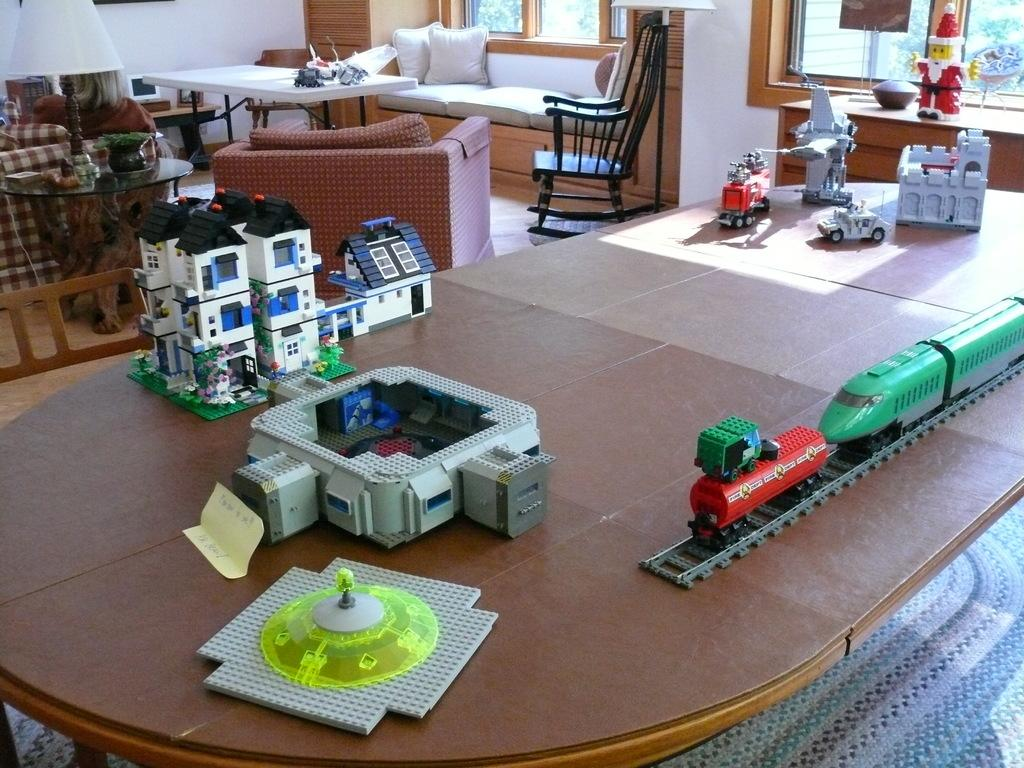What type of structure is visible in the image? There is a lego home in the image. What mode of transportation can be seen in the image? There is a train in the image. What other vehicles are present in the image? There are cars in the image. Where are these objects located? These objects are on a table. What can be seen in the background of the image? There is a sofa set and chairs in the background of the image. What type of room might this scene be in? The scene appears to be inside a living room. How many insects are crawling on the lego home in the image? There are no insects present in the image; it features a lego home, train, and cars on a table in a living room setting. How many men are visible in the image? There are no men present in the image; it features a lego home, train, and cars on a table in a living room setting. 